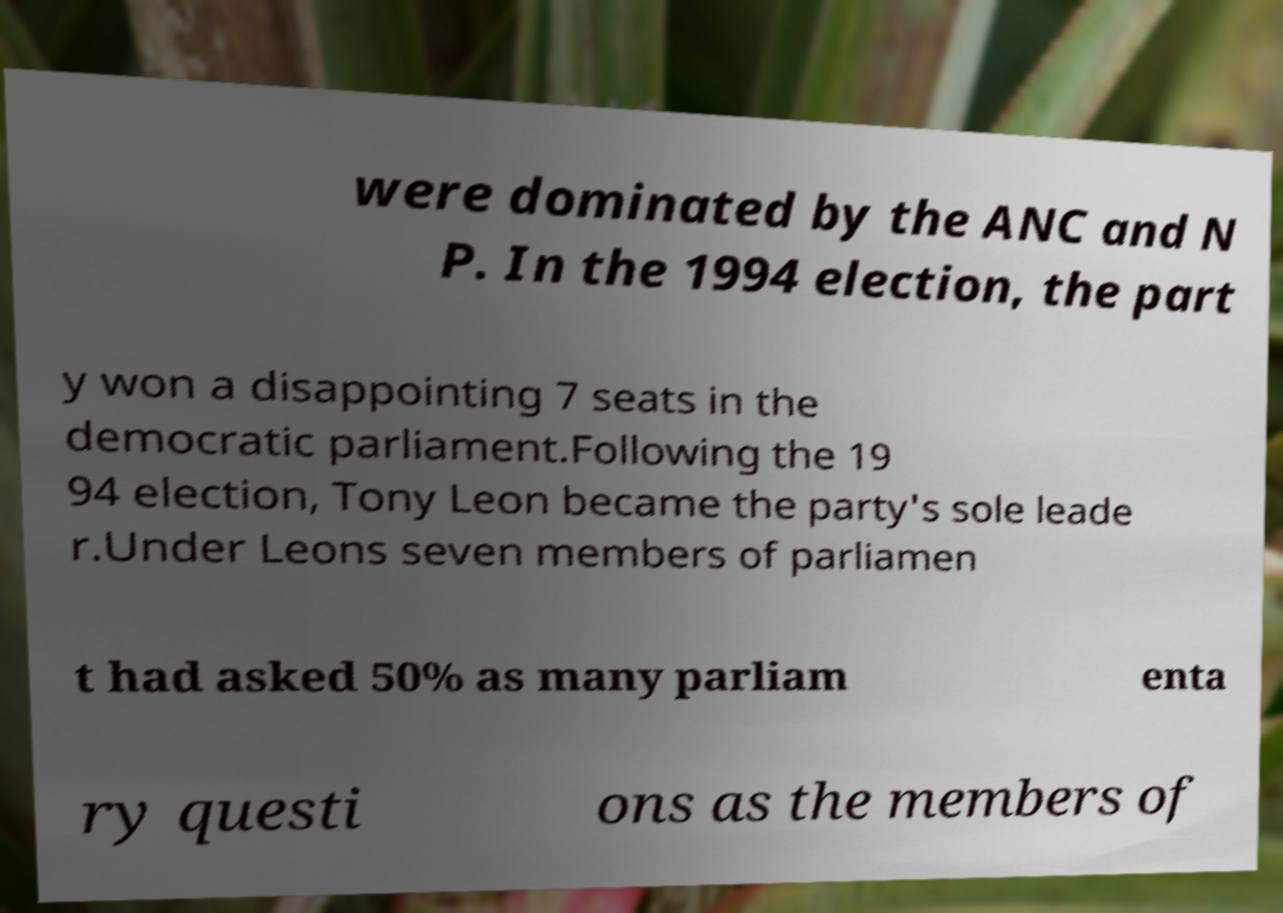Could you extract and type out the text from this image? were dominated by the ANC and N P. In the 1994 election, the part y won a disappointing 7 seats in the democratic parliament.Following the 19 94 election, Tony Leon became the party's sole leade r.Under Leons seven members of parliamen t had asked 50% as many parliam enta ry questi ons as the members of 